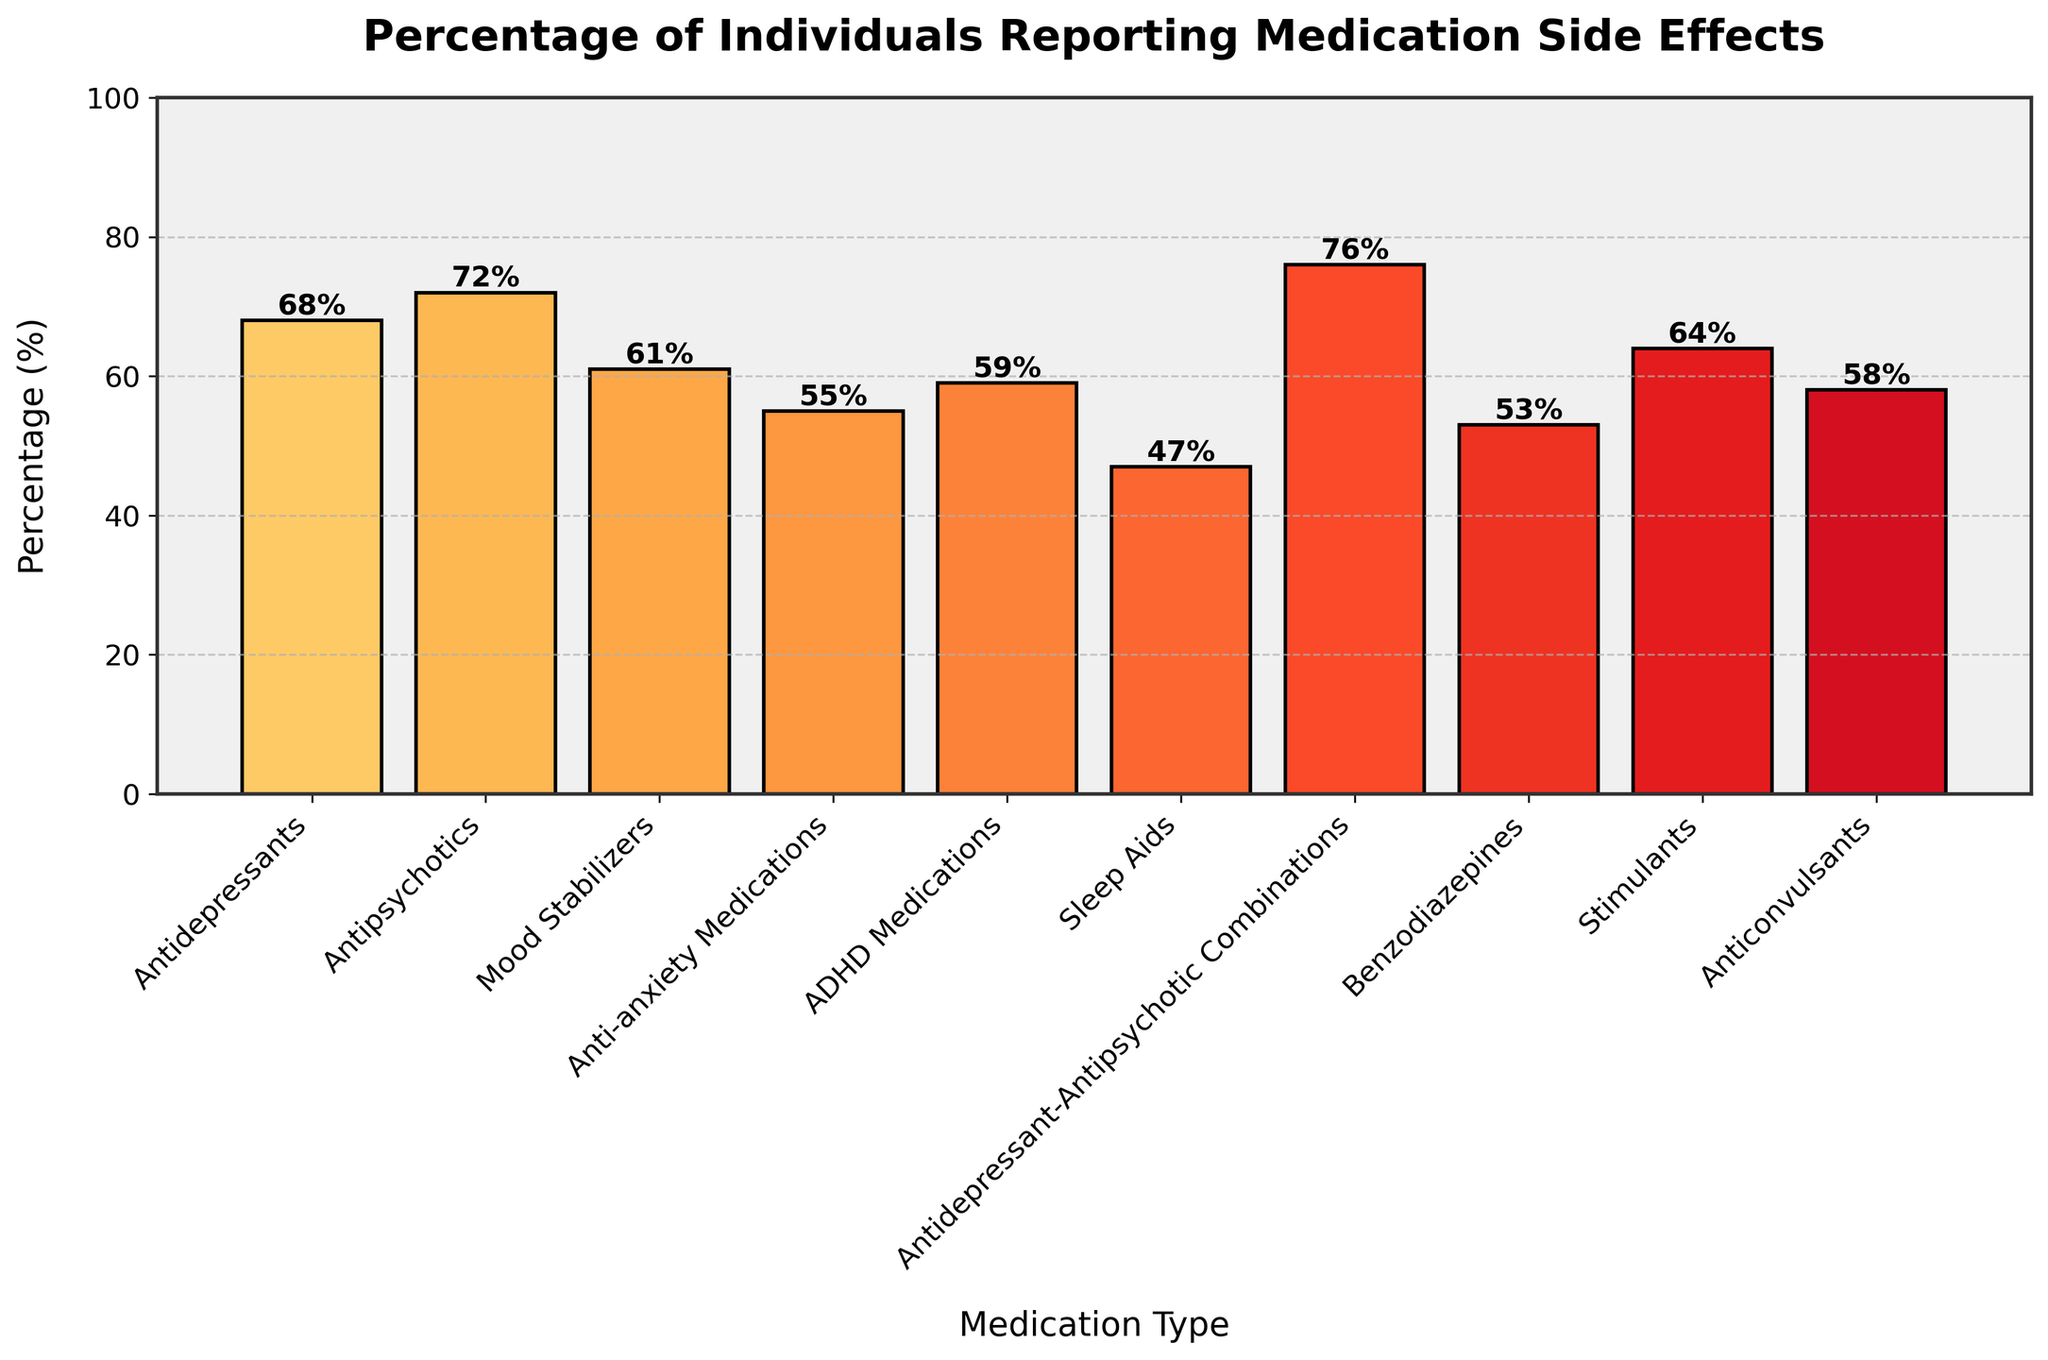Which medication reports the highest percentage of side effects? The bar for Antidepressant-Antipsychotic Combinations reaches the highest percentage at 76%, which is the tallest bar in the chart.
Answer: Antidepressant-Antipsychotic Combinations What is the percentage difference in reported side effects between Antidepressants and Antipsychotics? Antidepressants report 68%, and Antipsychotics report 72%. The difference is calculated as 72% - 68% = 4%.
Answer: 4% How many medications report side effects percentages above 60%? The medications with percentages above 60% are Antidepressants (68%), Antipsychotics (72%), Mood Stabilizers (61%), Antidepressant-Antipsychotic Combinations (76%), and Stimulants (64%). There are 5 medications in total.
Answer: 5 Which medication has the lowest reported side effects percentage and what is it? The shortest bar represents Sleep Aids, which has a percentage of 47%.
Answer: Sleep Aids, 47% Rank the medications from highest to lowest reported side effects percentages. List the medications and their respective percentages and then sort them: Antidepressant-Antipsychotic Combinations (76%), Antipsychotics (72%), Antidepressants (68%), Stimulants (64%), Mood Stabilizers (61%), ADHD Medications (59%), Anticonvulsants (58%), Anti-anxiety Medications (55%), Benzodiazepines (53%), and Sleep Aids (47%).
Answer: Antidepressant-Antipsychotic Combinations, Antipsychotics, Antidepressants, Stimulants, Mood Stabilizers, ADHD Medications, Anticonvulsants, Anti-anxiety Medications, Benzodiazepines, Sleep Aids Which medication pairs have a difference in reported side effects of exactly 5 percentage points? Compare percentages for each possible pair: Mood Stabilizers (61%) - Anti-anxiety Medications (55%) is 61% - 55% = 6% (not 5%); Anti-anxiety Medications (55%) - ADHD Medications (59%) is 59% - 55% = 4% (not 5%); Benzodiazepines (53%) - Anticonvulsants (58%) is 58% - 53% = 5%. The pairs are Anticonvulsants and Benzodiazepines.
Answer: Anticonvulsants and Benzodiazepines What is the average percentage of side effects reported across all medications? Sum all the percentages and divide by the number of medications: (68% + 72% + 61% + 55% + 59% + 47% + 76% + 53% + 64% + 58%) / 10. The total sum is 613%, and the average is 613 / 10 = 61.3%.
Answer: 61.3% Which is more common, medications with side effects at or above the mean percentage or below? Calculate the mean (61.3%). Medications at or above 61.3% are Antidepressants, Antipsychotics, Mood Stabilizers, Stimulants, and Antidepressant-Antipsychotic Combinations. Medications below are Anti-anxiety Medications, ADHD Medications, Sleep Aids, Benzodiazepines, and Anticonvulsants. Each count is 5.
Answer: They are equal Between Anti-anxiety Medications and ADHD Medications, which has fewer reported side effects? Compare the bar heights labeled for Anti-anxiety Medications (55%) and ADHD Medications (59%). Anti-anxiety Medications report fewer side effects at 55%.
Answer: Anti-anxiety Medications What is the range of reported side effects percentages? The range is found by subtracting the lowest percentage from the highest percentage. The highest is 76% (Antidepressant-Antipsychotic Combinations) and the lowest is 47% (Sleep Aids). The range is 76% - 47% = 29%.
Answer: 29% 